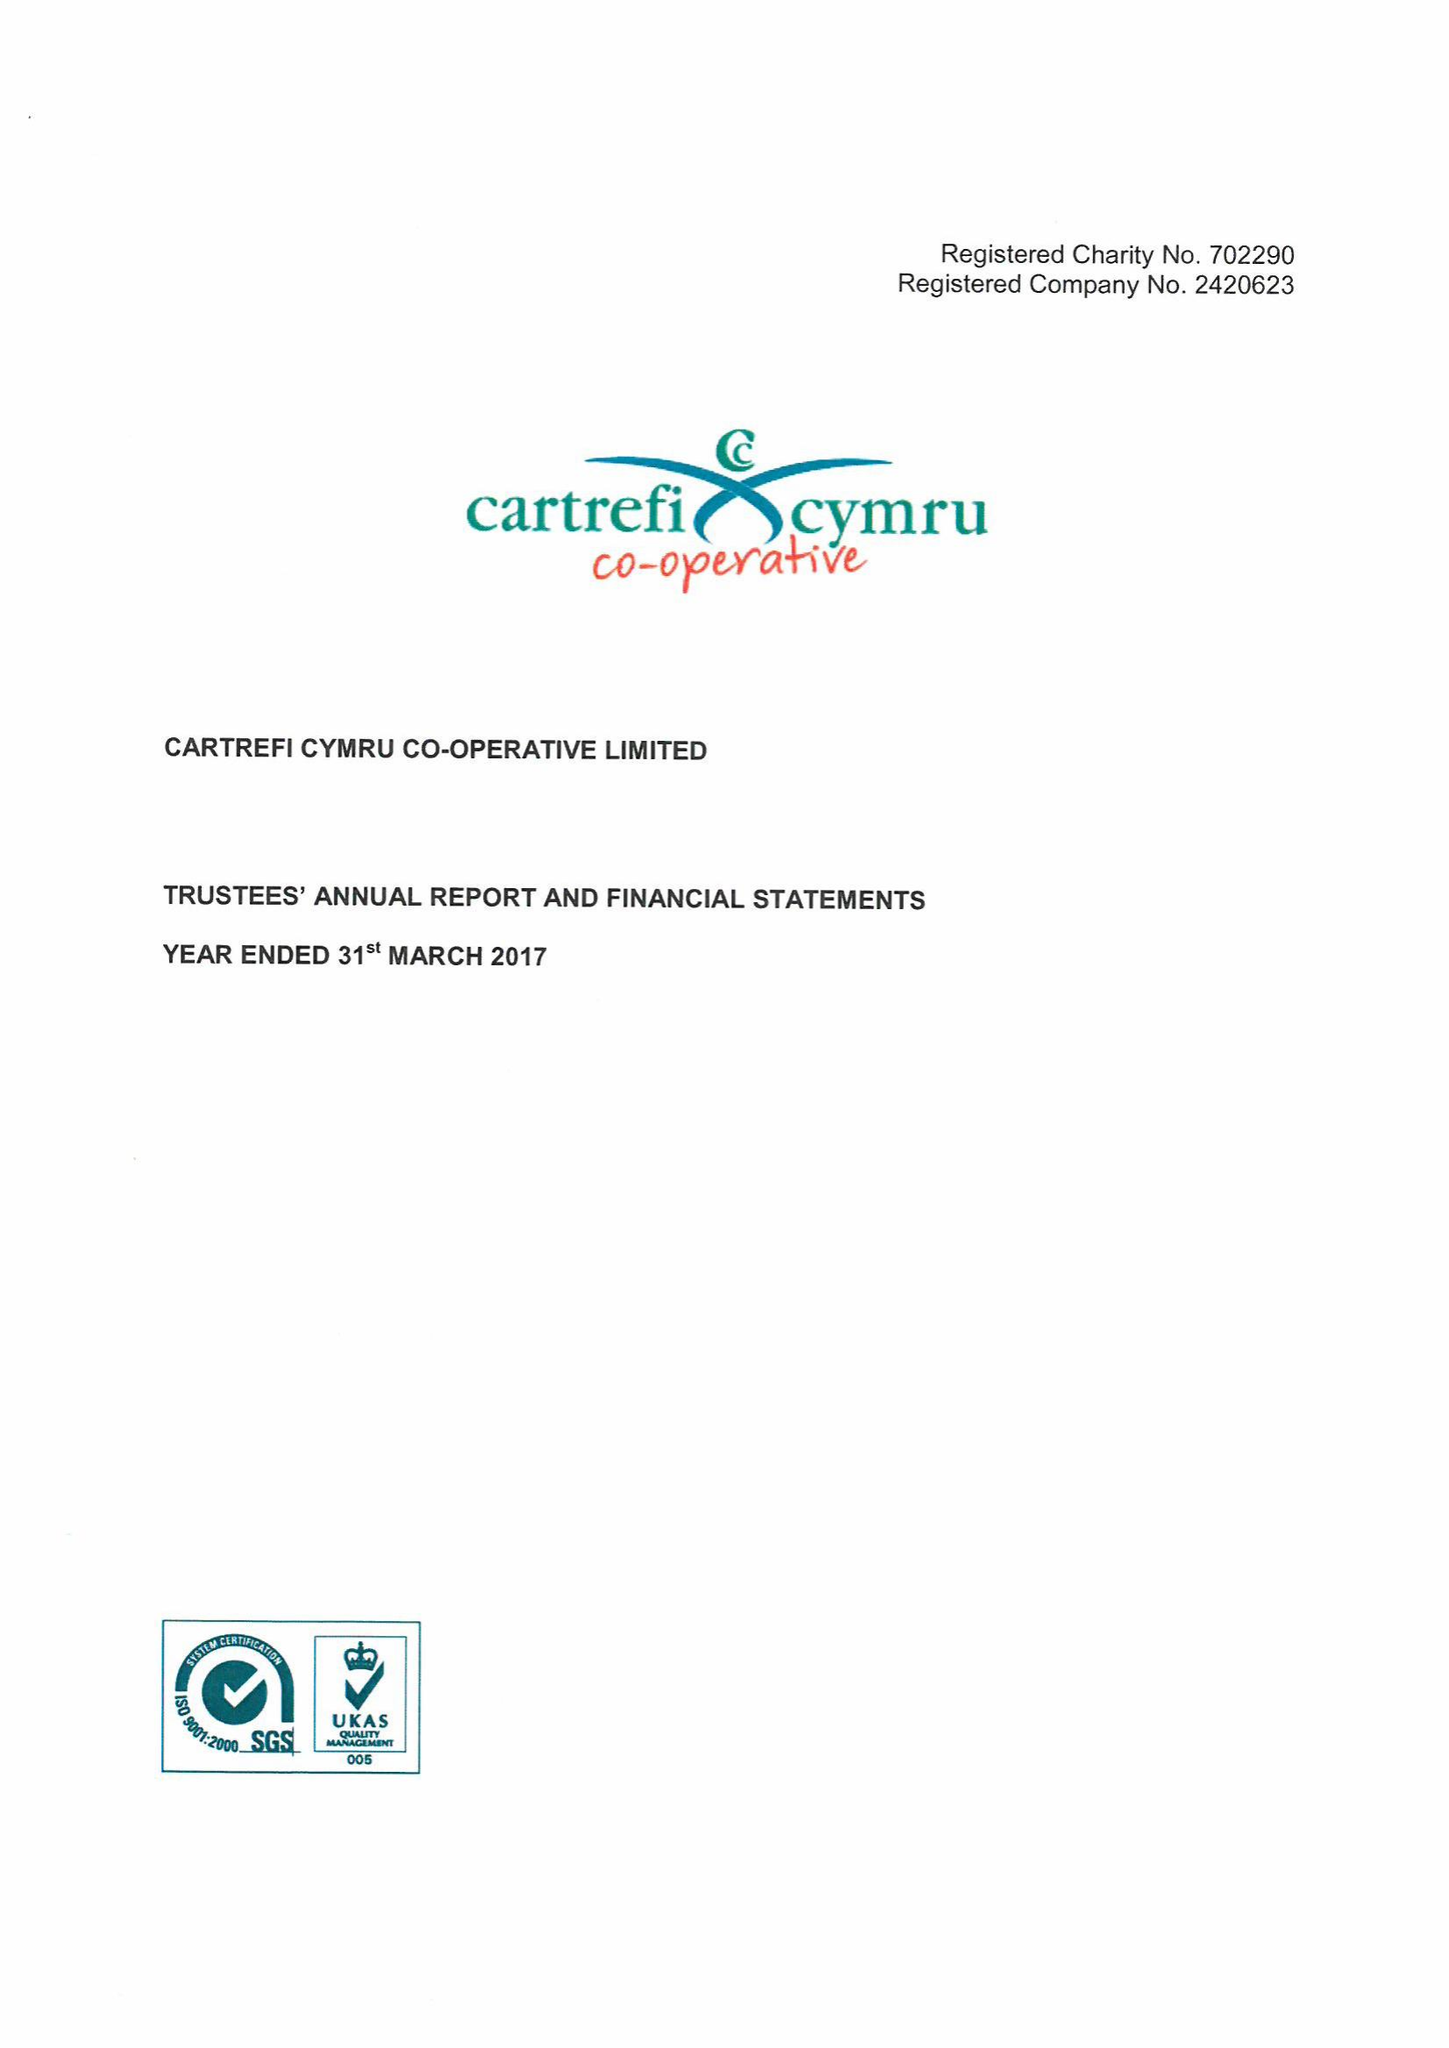What is the value for the address__postcode?
Answer the question using a single word or phrase. CF10 5NB 